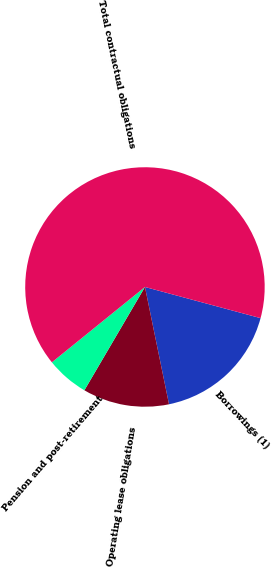<chart> <loc_0><loc_0><loc_500><loc_500><pie_chart><fcel>Borrowings (1)<fcel>Operating lease obligations<fcel>Pension and post-retirement<fcel>Total contractual obligations<nl><fcel>17.59%<fcel>11.66%<fcel>5.73%<fcel>65.02%<nl></chart> 